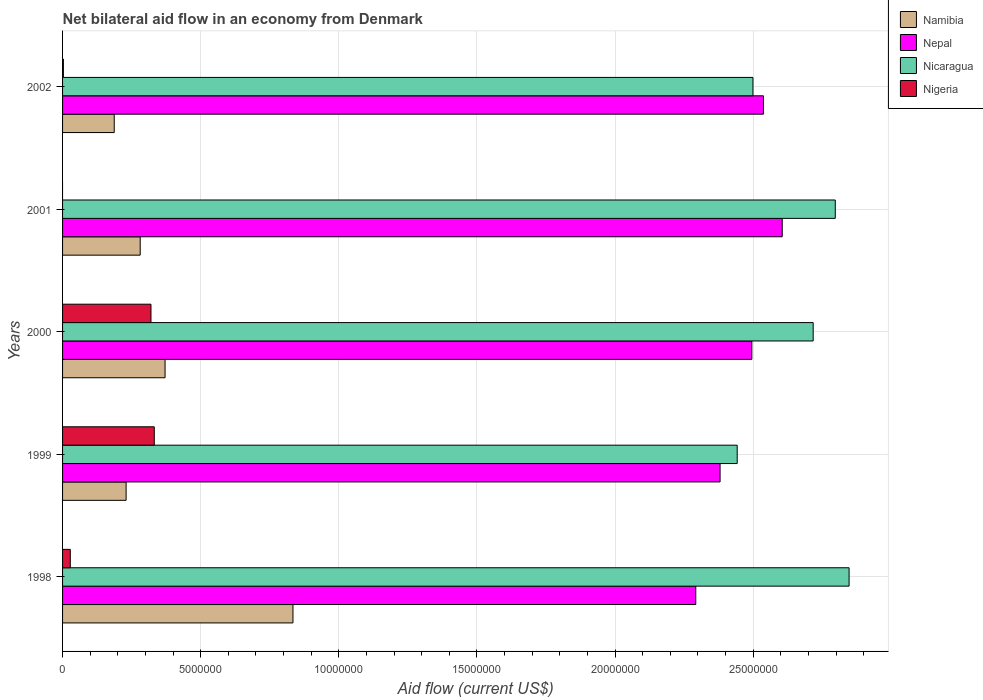Are the number of bars on each tick of the Y-axis equal?
Your answer should be compact. No. How many bars are there on the 4th tick from the top?
Offer a very short reply. 4. In how many cases, is the number of bars for a given year not equal to the number of legend labels?
Give a very brief answer. 1. What is the net bilateral aid flow in Nepal in 2000?
Provide a short and direct response. 2.50e+07. Across all years, what is the maximum net bilateral aid flow in Nigeria?
Your answer should be very brief. 3.32e+06. Across all years, what is the minimum net bilateral aid flow in Nicaragua?
Your response must be concise. 2.44e+07. What is the total net bilateral aid flow in Nepal in the graph?
Provide a short and direct response. 1.23e+08. What is the difference between the net bilateral aid flow in Namibia in 2000 and that in 2002?
Offer a very short reply. 1.84e+06. What is the difference between the net bilateral aid flow in Nigeria in 1999 and the net bilateral aid flow in Nepal in 2002?
Your response must be concise. -2.20e+07. What is the average net bilateral aid flow in Nigeria per year?
Give a very brief answer. 1.37e+06. In the year 2002, what is the difference between the net bilateral aid flow in Nicaragua and net bilateral aid flow in Nigeria?
Make the answer very short. 2.50e+07. What is the ratio of the net bilateral aid flow in Namibia in 2000 to that in 2001?
Keep it short and to the point. 1.32. What is the difference between the highest and the lowest net bilateral aid flow in Namibia?
Keep it short and to the point. 6.47e+06. Are all the bars in the graph horizontal?
Your response must be concise. Yes. How many years are there in the graph?
Offer a terse response. 5. Are the values on the major ticks of X-axis written in scientific E-notation?
Ensure brevity in your answer.  No. Where does the legend appear in the graph?
Offer a terse response. Top right. How are the legend labels stacked?
Offer a very short reply. Vertical. What is the title of the graph?
Provide a short and direct response. Net bilateral aid flow in an economy from Denmark. What is the label or title of the X-axis?
Your answer should be compact. Aid flow (current US$). What is the Aid flow (current US$) of Namibia in 1998?
Your answer should be compact. 8.34e+06. What is the Aid flow (current US$) in Nepal in 1998?
Your answer should be very brief. 2.29e+07. What is the Aid flow (current US$) in Nicaragua in 1998?
Offer a terse response. 2.85e+07. What is the Aid flow (current US$) in Namibia in 1999?
Your answer should be very brief. 2.30e+06. What is the Aid flow (current US$) in Nepal in 1999?
Ensure brevity in your answer.  2.38e+07. What is the Aid flow (current US$) of Nicaragua in 1999?
Provide a succinct answer. 2.44e+07. What is the Aid flow (current US$) in Nigeria in 1999?
Ensure brevity in your answer.  3.32e+06. What is the Aid flow (current US$) in Namibia in 2000?
Provide a short and direct response. 3.71e+06. What is the Aid flow (current US$) of Nepal in 2000?
Provide a succinct answer. 2.50e+07. What is the Aid flow (current US$) of Nicaragua in 2000?
Provide a short and direct response. 2.72e+07. What is the Aid flow (current US$) in Nigeria in 2000?
Keep it short and to the point. 3.20e+06. What is the Aid flow (current US$) in Namibia in 2001?
Keep it short and to the point. 2.81e+06. What is the Aid flow (current US$) of Nepal in 2001?
Your answer should be compact. 2.60e+07. What is the Aid flow (current US$) in Nicaragua in 2001?
Offer a terse response. 2.80e+07. What is the Aid flow (current US$) of Namibia in 2002?
Your answer should be very brief. 1.87e+06. What is the Aid flow (current US$) of Nepal in 2002?
Give a very brief answer. 2.54e+07. What is the Aid flow (current US$) in Nicaragua in 2002?
Provide a succinct answer. 2.50e+07. Across all years, what is the maximum Aid flow (current US$) in Namibia?
Provide a succinct answer. 8.34e+06. Across all years, what is the maximum Aid flow (current US$) of Nepal?
Keep it short and to the point. 2.60e+07. Across all years, what is the maximum Aid flow (current US$) of Nicaragua?
Offer a terse response. 2.85e+07. Across all years, what is the maximum Aid flow (current US$) of Nigeria?
Your answer should be very brief. 3.32e+06. Across all years, what is the minimum Aid flow (current US$) of Namibia?
Your response must be concise. 1.87e+06. Across all years, what is the minimum Aid flow (current US$) of Nepal?
Keep it short and to the point. 2.29e+07. Across all years, what is the minimum Aid flow (current US$) in Nicaragua?
Keep it short and to the point. 2.44e+07. Across all years, what is the minimum Aid flow (current US$) in Nigeria?
Provide a short and direct response. 0. What is the total Aid flow (current US$) in Namibia in the graph?
Your response must be concise. 1.90e+07. What is the total Aid flow (current US$) in Nepal in the graph?
Your response must be concise. 1.23e+08. What is the total Aid flow (current US$) in Nicaragua in the graph?
Give a very brief answer. 1.33e+08. What is the total Aid flow (current US$) in Nigeria in the graph?
Give a very brief answer. 6.83e+06. What is the difference between the Aid flow (current US$) in Namibia in 1998 and that in 1999?
Provide a short and direct response. 6.04e+06. What is the difference between the Aid flow (current US$) in Nepal in 1998 and that in 1999?
Ensure brevity in your answer.  -8.80e+05. What is the difference between the Aid flow (current US$) of Nicaragua in 1998 and that in 1999?
Ensure brevity in your answer.  4.05e+06. What is the difference between the Aid flow (current US$) in Nigeria in 1998 and that in 1999?
Keep it short and to the point. -3.04e+06. What is the difference between the Aid flow (current US$) in Namibia in 1998 and that in 2000?
Offer a terse response. 4.63e+06. What is the difference between the Aid flow (current US$) in Nepal in 1998 and that in 2000?
Your answer should be compact. -2.03e+06. What is the difference between the Aid flow (current US$) of Nicaragua in 1998 and that in 2000?
Make the answer very short. 1.30e+06. What is the difference between the Aid flow (current US$) of Nigeria in 1998 and that in 2000?
Your answer should be very brief. -2.92e+06. What is the difference between the Aid flow (current US$) in Namibia in 1998 and that in 2001?
Provide a short and direct response. 5.53e+06. What is the difference between the Aid flow (current US$) in Nepal in 1998 and that in 2001?
Provide a succinct answer. -3.13e+06. What is the difference between the Aid flow (current US$) in Nicaragua in 1998 and that in 2001?
Keep it short and to the point. 5.00e+05. What is the difference between the Aid flow (current US$) of Namibia in 1998 and that in 2002?
Offer a terse response. 6.47e+06. What is the difference between the Aid flow (current US$) in Nepal in 1998 and that in 2002?
Your answer should be compact. -2.45e+06. What is the difference between the Aid flow (current US$) of Nicaragua in 1998 and that in 2002?
Your answer should be very brief. 3.48e+06. What is the difference between the Aid flow (current US$) of Nigeria in 1998 and that in 2002?
Give a very brief answer. 2.50e+05. What is the difference between the Aid flow (current US$) in Namibia in 1999 and that in 2000?
Offer a terse response. -1.41e+06. What is the difference between the Aid flow (current US$) in Nepal in 1999 and that in 2000?
Keep it short and to the point. -1.15e+06. What is the difference between the Aid flow (current US$) in Nicaragua in 1999 and that in 2000?
Provide a succinct answer. -2.75e+06. What is the difference between the Aid flow (current US$) in Nigeria in 1999 and that in 2000?
Provide a short and direct response. 1.20e+05. What is the difference between the Aid flow (current US$) in Namibia in 1999 and that in 2001?
Offer a terse response. -5.10e+05. What is the difference between the Aid flow (current US$) of Nepal in 1999 and that in 2001?
Your response must be concise. -2.25e+06. What is the difference between the Aid flow (current US$) of Nicaragua in 1999 and that in 2001?
Make the answer very short. -3.55e+06. What is the difference between the Aid flow (current US$) in Nepal in 1999 and that in 2002?
Keep it short and to the point. -1.57e+06. What is the difference between the Aid flow (current US$) in Nicaragua in 1999 and that in 2002?
Provide a succinct answer. -5.70e+05. What is the difference between the Aid flow (current US$) of Nigeria in 1999 and that in 2002?
Offer a terse response. 3.29e+06. What is the difference between the Aid flow (current US$) in Nepal in 2000 and that in 2001?
Offer a terse response. -1.10e+06. What is the difference between the Aid flow (current US$) of Nicaragua in 2000 and that in 2001?
Make the answer very short. -8.00e+05. What is the difference between the Aid flow (current US$) in Namibia in 2000 and that in 2002?
Offer a very short reply. 1.84e+06. What is the difference between the Aid flow (current US$) in Nepal in 2000 and that in 2002?
Offer a terse response. -4.20e+05. What is the difference between the Aid flow (current US$) of Nicaragua in 2000 and that in 2002?
Make the answer very short. 2.18e+06. What is the difference between the Aid flow (current US$) of Nigeria in 2000 and that in 2002?
Your response must be concise. 3.17e+06. What is the difference between the Aid flow (current US$) in Namibia in 2001 and that in 2002?
Your answer should be very brief. 9.40e+05. What is the difference between the Aid flow (current US$) in Nepal in 2001 and that in 2002?
Give a very brief answer. 6.80e+05. What is the difference between the Aid flow (current US$) in Nicaragua in 2001 and that in 2002?
Provide a short and direct response. 2.98e+06. What is the difference between the Aid flow (current US$) in Namibia in 1998 and the Aid flow (current US$) in Nepal in 1999?
Your response must be concise. -1.55e+07. What is the difference between the Aid flow (current US$) of Namibia in 1998 and the Aid flow (current US$) of Nicaragua in 1999?
Your response must be concise. -1.61e+07. What is the difference between the Aid flow (current US$) of Namibia in 1998 and the Aid flow (current US$) of Nigeria in 1999?
Your response must be concise. 5.02e+06. What is the difference between the Aid flow (current US$) in Nepal in 1998 and the Aid flow (current US$) in Nicaragua in 1999?
Make the answer very short. -1.50e+06. What is the difference between the Aid flow (current US$) of Nepal in 1998 and the Aid flow (current US$) of Nigeria in 1999?
Offer a very short reply. 1.96e+07. What is the difference between the Aid flow (current US$) in Nicaragua in 1998 and the Aid flow (current US$) in Nigeria in 1999?
Your answer should be compact. 2.52e+07. What is the difference between the Aid flow (current US$) in Namibia in 1998 and the Aid flow (current US$) in Nepal in 2000?
Your answer should be compact. -1.66e+07. What is the difference between the Aid flow (current US$) of Namibia in 1998 and the Aid flow (current US$) of Nicaragua in 2000?
Keep it short and to the point. -1.88e+07. What is the difference between the Aid flow (current US$) in Namibia in 1998 and the Aid flow (current US$) in Nigeria in 2000?
Your answer should be compact. 5.14e+06. What is the difference between the Aid flow (current US$) in Nepal in 1998 and the Aid flow (current US$) in Nicaragua in 2000?
Ensure brevity in your answer.  -4.25e+06. What is the difference between the Aid flow (current US$) of Nepal in 1998 and the Aid flow (current US$) of Nigeria in 2000?
Make the answer very short. 1.97e+07. What is the difference between the Aid flow (current US$) in Nicaragua in 1998 and the Aid flow (current US$) in Nigeria in 2000?
Your response must be concise. 2.53e+07. What is the difference between the Aid flow (current US$) in Namibia in 1998 and the Aid flow (current US$) in Nepal in 2001?
Your response must be concise. -1.77e+07. What is the difference between the Aid flow (current US$) of Namibia in 1998 and the Aid flow (current US$) of Nicaragua in 2001?
Offer a terse response. -1.96e+07. What is the difference between the Aid flow (current US$) of Nepal in 1998 and the Aid flow (current US$) of Nicaragua in 2001?
Provide a succinct answer. -5.05e+06. What is the difference between the Aid flow (current US$) of Namibia in 1998 and the Aid flow (current US$) of Nepal in 2002?
Make the answer very short. -1.70e+07. What is the difference between the Aid flow (current US$) in Namibia in 1998 and the Aid flow (current US$) in Nicaragua in 2002?
Keep it short and to the point. -1.66e+07. What is the difference between the Aid flow (current US$) in Namibia in 1998 and the Aid flow (current US$) in Nigeria in 2002?
Your answer should be compact. 8.31e+06. What is the difference between the Aid flow (current US$) in Nepal in 1998 and the Aid flow (current US$) in Nicaragua in 2002?
Offer a very short reply. -2.07e+06. What is the difference between the Aid flow (current US$) of Nepal in 1998 and the Aid flow (current US$) of Nigeria in 2002?
Offer a very short reply. 2.29e+07. What is the difference between the Aid flow (current US$) in Nicaragua in 1998 and the Aid flow (current US$) in Nigeria in 2002?
Offer a very short reply. 2.84e+07. What is the difference between the Aid flow (current US$) of Namibia in 1999 and the Aid flow (current US$) of Nepal in 2000?
Ensure brevity in your answer.  -2.26e+07. What is the difference between the Aid flow (current US$) of Namibia in 1999 and the Aid flow (current US$) of Nicaragua in 2000?
Provide a short and direct response. -2.49e+07. What is the difference between the Aid flow (current US$) in Namibia in 1999 and the Aid flow (current US$) in Nigeria in 2000?
Keep it short and to the point. -9.00e+05. What is the difference between the Aid flow (current US$) of Nepal in 1999 and the Aid flow (current US$) of Nicaragua in 2000?
Your answer should be compact. -3.37e+06. What is the difference between the Aid flow (current US$) in Nepal in 1999 and the Aid flow (current US$) in Nigeria in 2000?
Give a very brief answer. 2.06e+07. What is the difference between the Aid flow (current US$) in Nicaragua in 1999 and the Aid flow (current US$) in Nigeria in 2000?
Make the answer very short. 2.12e+07. What is the difference between the Aid flow (current US$) of Namibia in 1999 and the Aid flow (current US$) of Nepal in 2001?
Provide a succinct answer. -2.38e+07. What is the difference between the Aid flow (current US$) in Namibia in 1999 and the Aid flow (current US$) in Nicaragua in 2001?
Offer a very short reply. -2.57e+07. What is the difference between the Aid flow (current US$) of Nepal in 1999 and the Aid flow (current US$) of Nicaragua in 2001?
Offer a terse response. -4.17e+06. What is the difference between the Aid flow (current US$) of Namibia in 1999 and the Aid flow (current US$) of Nepal in 2002?
Offer a very short reply. -2.31e+07. What is the difference between the Aid flow (current US$) of Namibia in 1999 and the Aid flow (current US$) of Nicaragua in 2002?
Ensure brevity in your answer.  -2.27e+07. What is the difference between the Aid flow (current US$) in Namibia in 1999 and the Aid flow (current US$) in Nigeria in 2002?
Ensure brevity in your answer.  2.27e+06. What is the difference between the Aid flow (current US$) in Nepal in 1999 and the Aid flow (current US$) in Nicaragua in 2002?
Your response must be concise. -1.19e+06. What is the difference between the Aid flow (current US$) of Nepal in 1999 and the Aid flow (current US$) of Nigeria in 2002?
Your response must be concise. 2.38e+07. What is the difference between the Aid flow (current US$) in Nicaragua in 1999 and the Aid flow (current US$) in Nigeria in 2002?
Provide a succinct answer. 2.44e+07. What is the difference between the Aid flow (current US$) in Namibia in 2000 and the Aid flow (current US$) in Nepal in 2001?
Make the answer very short. -2.23e+07. What is the difference between the Aid flow (current US$) of Namibia in 2000 and the Aid flow (current US$) of Nicaragua in 2001?
Provide a succinct answer. -2.43e+07. What is the difference between the Aid flow (current US$) in Nepal in 2000 and the Aid flow (current US$) in Nicaragua in 2001?
Keep it short and to the point. -3.02e+06. What is the difference between the Aid flow (current US$) in Namibia in 2000 and the Aid flow (current US$) in Nepal in 2002?
Offer a very short reply. -2.17e+07. What is the difference between the Aid flow (current US$) of Namibia in 2000 and the Aid flow (current US$) of Nicaragua in 2002?
Your answer should be compact. -2.13e+07. What is the difference between the Aid flow (current US$) in Namibia in 2000 and the Aid flow (current US$) in Nigeria in 2002?
Make the answer very short. 3.68e+06. What is the difference between the Aid flow (current US$) in Nepal in 2000 and the Aid flow (current US$) in Nigeria in 2002?
Your answer should be very brief. 2.49e+07. What is the difference between the Aid flow (current US$) of Nicaragua in 2000 and the Aid flow (current US$) of Nigeria in 2002?
Make the answer very short. 2.71e+07. What is the difference between the Aid flow (current US$) in Namibia in 2001 and the Aid flow (current US$) in Nepal in 2002?
Make the answer very short. -2.26e+07. What is the difference between the Aid flow (current US$) in Namibia in 2001 and the Aid flow (current US$) in Nicaragua in 2002?
Make the answer very short. -2.22e+07. What is the difference between the Aid flow (current US$) in Namibia in 2001 and the Aid flow (current US$) in Nigeria in 2002?
Your answer should be very brief. 2.78e+06. What is the difference between the Aid flow (current US$) of Nepal in 2001 and the Aid flow (current US$) of Nicaragua in 2002?
Your answer should be very brief. 1.06e+06. What is the difference between the Aid flow (current US$) in Nepal in 2001 and the Aid flow (current US$) in Nigeria in 2002?
Provide a succinct answer. 2.60e+07. What is the difference between the Aid flow (current US$) in Nicaragua in 2001 and the Aid flow (current US$) in Nigeria in 2002?
Give a very brief answer. 2.79e+07. What is the average Aid flow (current US$) in Namibia per year?
Your answer should be very brief. 3.81e+06. What is the average Aid flow (current US$) in Nepal per year?
Your response must be concise. 2.46e+07. What is the average Aid flow (current US$) in Nicaragua per year?
Offer a very short reply. 2.66e+07. What is the average Aid flow (current US$) of Nigeria per year?
Provide a short and direct response. 1.37e+06. In the year 1998, what is the difference between the Aid flow (current US$) of Namibia and Aid flow (current US$) of Nepal?
Make the answer very short. -1.46e+07. In the year 1998, what is the difference between the Aid flow (current US$) in Namibia and Aid flow (current US$) in Nicaragua?
Give a very brief answer. -2.01e+07. In the year 1998, what is the difference between the Aid flow (current US$) in Namibia and Aid flow (current US$) in Nigeria?
Offer a very short reply. 8.06e+06. In the year 1998, what is the difference between the Aid flow (current US$) of Nepal and Aid flow (current US$) of Nicaragua?
Your answer should be compact. -5.55e+06. In the year 1998, what is the difference between the Aid flow (current US$) in Nepal and Aid flow (current US$) in Nigeria?
Your answer should be compact. 2.26e+07. In the year 1998, what is the difference between the Aid flow (current US$) of Nicaragua and Aid flow (current US$) of Nigeria?
Make the answer very short. 2.82e+07. In the year 1999, what is the difference between the Aid flow (current US$) in Namibia and Aid flow (current US$) in Nepal?
Offer a terse response. -2.15e+07. In the year 1999, what is the difference between the Aid flow (current US$) of Namibia and Aid flow (current US$) of Nicaragua?
Provide a succinct answer. -2.21e+07. In the year 1999, what is the difference between the Aid flow (current US$) in Namibia and Aid flow (current US$) in Nigeria?
Give a very brief answer. -1.02e+06. In the year 1999, what is the difference between the Aid flow (current US$) of Nepal and Aid flow (current US$) of Nicaragua?
Keep it short and to the point. -6.20e+05. In the year 1999, what is the difference between the Aid flow (current US$) of Nepal and Aid flow (current US$) of Nigeria?
Your answer should be very brief. 2.05e+07. In the year 1999, what is the difference between the Aid flow (current US$) of Nicaragua and Aid flow (current US$) of Nigeria?
Your response must be concise. 2.11e+07. In the year 2000, what is the difference between the Aid flow (current US$) in Namibia and Aid flow (current US$) in Nepal?
Give a very brief answer. -2.12e+07. In the year 2000, what is the difference between the Aid flow (current US$) of Namibia and Aid flow (current US$) of Nicaragua?
Offer a terse response. -2.35e+07. In the year 2000, what is the difference between the Aid flow (current US$) in Namibia and Aid flow (current US$) in Nigeria?
Keep it short and to the point. 5.10e+05. In the year 2000, what is the difference between the Aid flow (current US$) of Nepal and Aid flow (current US$) of Nicaragua?
Your response must be concise. -2.22e+06. In the year 2000, what is the difference between the Aid flow (current US$) of Nepal and Aid flow (current US$) of Nigeria?
Give a very brief answer. 2.18e+07. In the year 2000, what is the difference between the Aid flow (current US$) in Nicaragua and Aid flow (current US$) in Nigeria?
Provide a succinct answer. 2.40e+07. In the year 2001, what is the difference between the Aid flow (current US$) of Namibia and Aid flow (current US$) of Nepal?
Ensure brevity in your answer.  -2.32e+07. In the year 2001, what is the difference between the Aid flow (current US$) in Namibia and Aid flow (current US$) in Nicaragua?
Offer a very short reply. -2.52e+07. In the year 2001, what is the difference between the Aid flow (current US$) of Nepal and Aid flow (current US$) of Nicaragua?
Your response must be concise. -1.92e+06. In the year 2002, what is the difference between the Aid flow (current US$) of Namibia and Aid flow (current US$) of Nepal?
Provide a short and direct response. -2.35e+07. In the year 2002, what is the difference between the Aid flow (current US$) in Namibia and Aid flow (current US$) in Nicaragua?
Make the answer very short. -2.31e+07. In the year 2002, what is the difference between the Aid flow (current US$) in Namibia and Aid flow (current US$) in Nigeria?
Your answer should be compact. 1.84e+06. In the year 2002, what is the difference between the Aid flow (current US$) in Nepal and Aid flow (current US$) in Nicaragua?
Ensure brevity in your answer.  3.80e+05. In the year 2002, what is the difference between the Aid flow (current US$) in Nepal and Aid flow (current US$) in Nigeria?
Make the answer very short. 2.53e+07. In the year 2002, what is the difference between the Aid flow (current US$) of Nicaragua and Aid flow (current US$) of Nigeria?
Provide a succinct answer. 2.50e+07. What is the ratio of the Aid flow (current US$) in Namibia in 1998 to that in 1999?
Keep it short and to the point. 3.63. What is the ratio of the Aid flow (current US$) of Nicaragua in 1998 to that in 1999?
Ensure brevity in your answer.  1.17. What is the ratio of the Aid flow (current US$) in Nigeria in 1998 to that in 1999?
Your answer should be compact. 0.08. What is the ratio of the Aid flow (current US$) in Namibia in 1998 to that in 2000?
Keep it short and to the point. 2.25. What is the ratio of the Aid flow (current US$) of Nepal in 1998 to that in 2000?
Ensure brevity in your answer.  0.92. What is the ratio of the Aid flow (current US$) of Nicaragua in 1998 to that in 2000?
Offer a very short reply. 1.05. What is the ratio of the Aid flow (current US$) of Nigeria in 1998 to that in 2000?
Keep it short and to the point. 0.09. What is the ratio of the Aid flow (current US$) of Namibia in 1998 to that in 2001?
Offer a very short reply. 2.97. What is the ratio of the Aid flow (current US$) of Nepal in 1998 to that in 2001?
Your response must be concise. 0.88. What is the ratio of the Aid flow (current US$) of Nicaragua in 1998 to that in 2001?
Offer a very short reply. 1.02. What is the ratio of the Aid flow (current US$) of Namibia in 1998 to that in 2002?
Provide a short and direct response. 4.46. What is the ratio of the Aid flow (current US$) of Nepal in 1998 to that in 2002?
Give a very brief answer. 0.9. What is the ratio of the Aid flow (current US$) of Nicaragua in 1998 to that in 2002?
Give a very brief answer. 1.14. What is the ratio of the Aid flow (current US$) of Nigeria in 1998 to that in 2002?
Provide a short and direct response. 9.33. What is the ratio of the Aid flow (current US$) of Namibia in 1999 to that in 2000?
Your answer should be very brief. 0.62. What is the ratio of the Aid flow (current US$) of Nepal in 1999 to that in 2000?
Make the answer very short. 0.95. What is the ratio of the Aid flow (current US$) in Nicaragua in 1999 to that in 2000?
Your response must be concise. 0.9. What is the ratio of the Aid flow (current US$) of Nigeria in 1999 to that in 2000?
Your answer should be very brief. 1.04. What is the ratio of the Aid flow (current US$) in Namibia in 1999 to that in 2001?
Offer a terse response. 0.82. What is the ratio of the Aid flow (current US$) in Nepal in 1999 to that in 2001?
Give a very brief answer. 0.91. What is the ratio of the Aid flow (current US$) of Nicaragua in 1999 to that in 2001?
Your answer should be compact. 0.87. What is the ratio of the Aid flow (current US$) of Namibia in 1999 to that in 2002?
Provide a short and direct response. 1.23. What is the ratio of the Aid flow (current US$) in Nepal in 1999 to that in 2002?
Provide a short and direct response. 0.94. What is the ratio of the Aid flow (current US$) of Nicaragua in 1999 to that in 2002?
Your answer should be very brief. 0.98. What is the ratio of the Aid flow (current US$) in Nigeria in 1999 to that in 2002?
Your answer should be compact. 110.67. What is the ratio of the Aid flow (current US$) in Namibia in 2000 to that in 2001?
Provide a short and direct response. 1.32. What is the ratio of the Aid flow (current US$) of Nepal in 2000 to that in 2001?
Provide a succinct answer. 0.96. What is the ratio of the Aid flow (current US$) of Nicaragua in 2000 to that in 2001?
Make the answer very short. 0.97. What is the ratio of the Aid flow (current US$) of Namibia in 2000 to that in 2002?
Make the answer very short. 1.98. What is the ratio of the Aid flow (current US$) in Nepal in 2000 to that in 2002?
Offer a terse response. 0.98. What is the ratio of the Aid flow (current US$) in Nicaragua in 2000 to that in 2002?
Your response must be concise. 1.09. What is the ratio of the Aid flow (current US$) in Nigeria in 2000 to that in 2002?
Your answer should be very brief. 106.67. What is the ratio of the Aid flow (current US$) of Namibia in 2001 to that in 2002?
Offer a very short reply. 1.5. What is the ratio of the Aid flow (current US$) of Nepal in 2001 to that in 2002?
Provide a short and direct response. 1.03. What is the ratio of the Aid flow (current US$) in Nicaragua in 2001 to that in 2002?
Offer a very short reply. 1.12. What is the difference between the highest and the second highest Aid flow (current US$) of Namibia?
Your answer should be very brief. 4.63e+06. What is the difference between the highest and the second highest Aid flow (current US$) in Nepal?
Make the answer very short. 6.80e+05. What is the difference between the highest and the second highest Aid flow (current US$) of Nicaragua?
Make the answer very short. 5.00e+05. What is the difference between the highest and the lowest Aid flow (current US$) in Namibia?
Provide a short and direct response. 6.47e+06. What is the difference between the highest and the lowest Aid flow (current US$) of Nepal?
Offer a terse response. 3.13e+06. What is the difference between the highest and the lowest Aid flow (current US$) of Nicaragua?
Provide a succinct answer. 4.05e+06. What is the difference between the highest and the lowest Aid flow (current US$) in Nigeria?
Your response must be concise. 3.32e+06. 